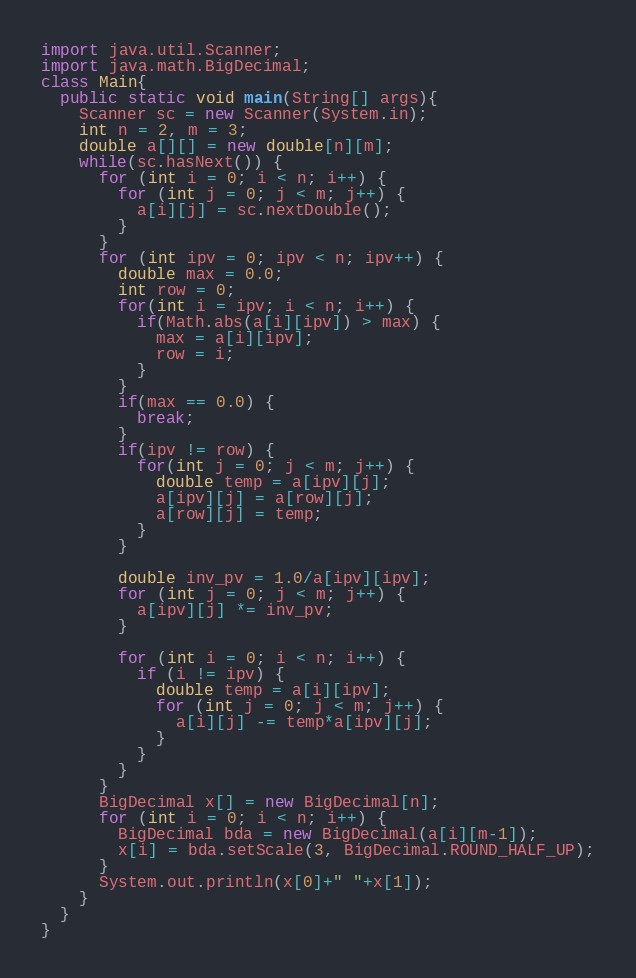<code> <loc_0><loc_0><loc_500><loc_500><_Java_>import java.util.Scanner;
import java.math.BigDecimal;
class Main{
  public static void main(String[] args){
    Scanner sc = new Scanner(System.in);
    int n = 2, m = 3;
    double a[][] = new double[n][m];
    while(sc.hasNext()) {
      for (int i = 0; i < n; i++) {
        for (int j = 0; j < m; j++) {
          a[i][j] = sc.nextDouble();
        }
      }
      for (int ipv = 0; ipv < n; ipv++) {
        double max = 0.0;
        int row = 0;
        for(int i = ipv; i < n; i++) {
          if(Math.abs(a[i][ipv]) > max) {
            max = a[i][ipv];
            row = i;
          }
        }
        if(max == 0.0) {
          break;
        }
        if(ipv != row) {
          for(int j = 0; j < m; j++) {
            double temp = a[ipv][j];
            a[ipv][j] = a[row][j];
            a[row][j] = temp;
          }
        }
        
        double inv_pv = 1.0/a[ipv][ipv];
        for (int j = 0; j < m; j++) {
          a[ipv][j] *= inv_pv;
        }
        
        for (int i = 0; i < n; i++) {
          if (i != ipv) {
            double temp = a[i][ipv];
            for (int j = 0; j < m; j++) {
              a[i][j] -= temp*a[ipv][j];
            }
          }
        }
      }
      BigDecimal x[] = new BigDecimal[n];
      for (int i = 0; i < n; i++) {
        BigDecimal bda = new BigDecimal(a[i][m-1]);
        x[i] = bda.setScale(3, BigDecimal.ROUND_HALF_UP);
      }
      System.out.println(x[0]+" "+x[1]);
    }
  }
}</code> 